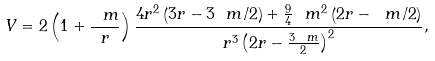Convert formula to latex. <formula><loc_0><loc_0><loc_500><loc_500>V = 2 \left ( 1 + \frac { \ m } { r } \right ) \frac { 4 r ^ { 2 } \left ( 3 r - 3 \ m / 2 \right ) + \frac { 9 } { 4 } \ m ^ { 2 } \left ( 2 r - \ m / 2 \right ) } { r ^ { 3 } \left ( 2 r - \frac { 3 \ m } { 2 } \right ) ^ { 2 } } ,</formula> 